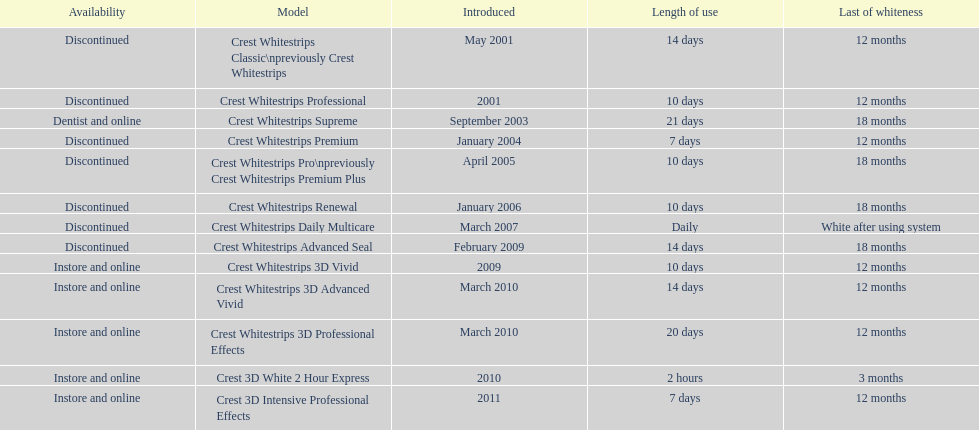How many models require less than a week of use? 2. 